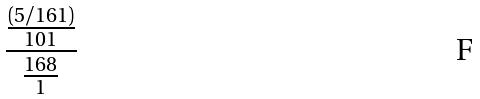<formula> <loc_0><loc_0><loc_500><loc_500>\frac { \frac { ( 5 / 1 6 1 ) } { 1 0 1 } } { \frac { 1 6 8 } { 1 } }</formula> 